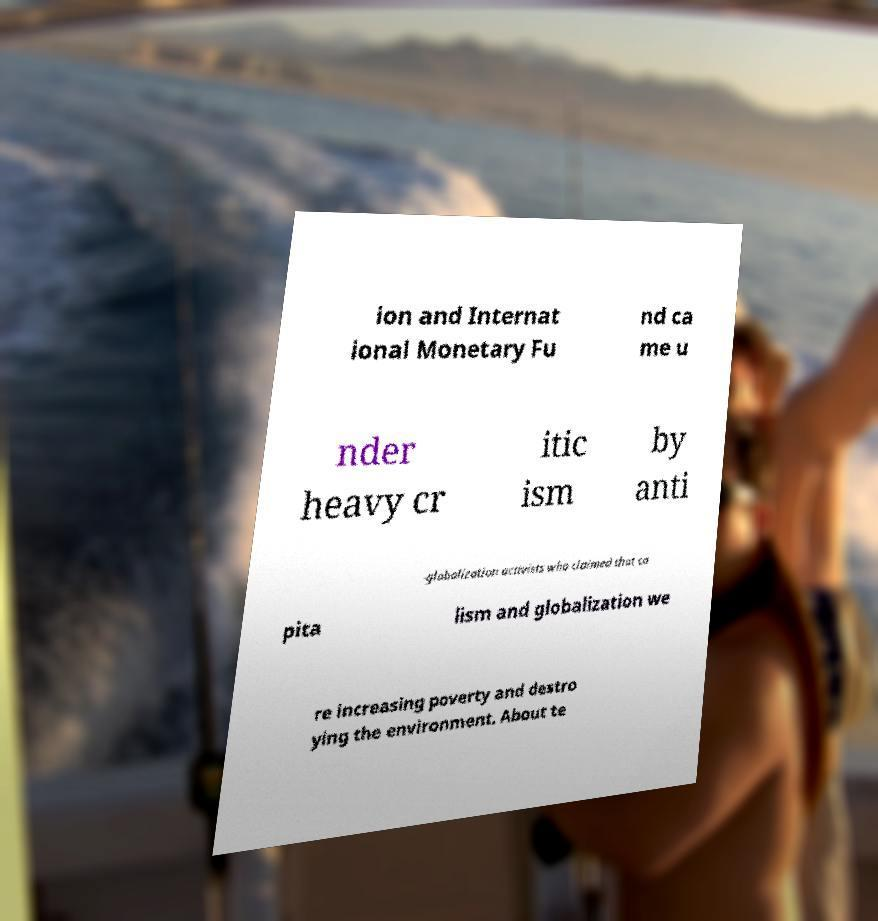Could you assist in decoding the text presented in this image and type it out clearly? ion and Internat ional Monetary Fu nd ca me u nder heavy cr itic ism by anti -globalization activists who claimed that ca pita lism and globalization we re increasing poverty and destro ying the environment. About te 